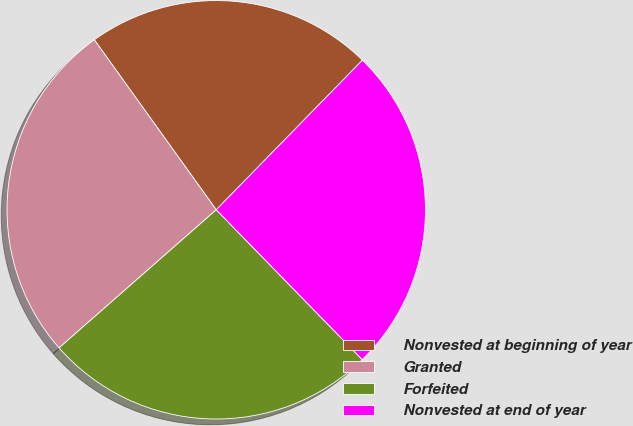Convert chart. <chart><loc_0><loc_0><loc_500><loc_500><pie_chart><fcel>Nonvested at beginning of year<fcel>Granted<fcel>Forfeited<fcel>Nonvested at end of year<nl><fcel>22.22%<fcel>26.57%<fcel>25.82%<fcel>25.39%<nl></chart> 